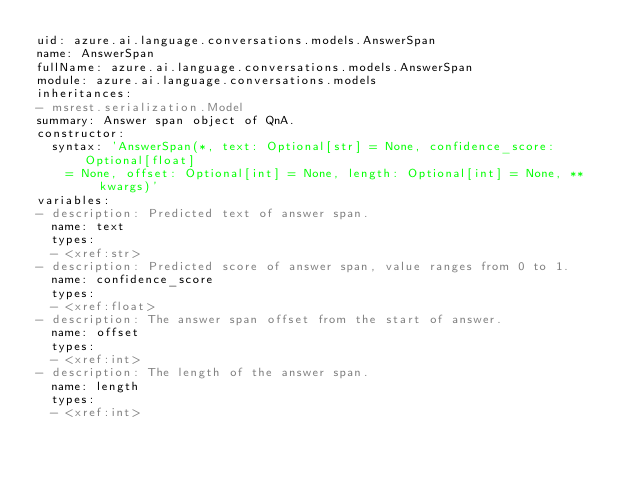Convert code to text. <code><loc_0><loc_0><loc_500><loc_500><_YAML_>uid: azure.ai.language.conversations.models.AnswerSpan
name: AnswerSpan
fullName: azure.ai.language.conversations.models.AnswerSpan
module: azure.ai.language.conversations.models
inheritances:
- msrest.serialization.Model
summary: Answer span object of QnA.
constructor:
  syntax: 'AnswerSpan(*, text: Optional[str] = None, confidence_score: Optional[float]
    = None, offset: Optional[int] = None, length: Optional[int] = None, **kwargs)'
variables:
- description: Predicted text of answer span.
  name: text
  types:
  - <xref:str>
- description: Predicted score of answer span, value ranges from 0 to 1.
  name: confidence_score
  types:
  - <xref:float>
- description: The answer span offset from the start of answer.
  name: offset
  types:
  - <xref:int>
- description: The length of the answer span.
  name: length
  types:
  - <xref:int>
</code> 